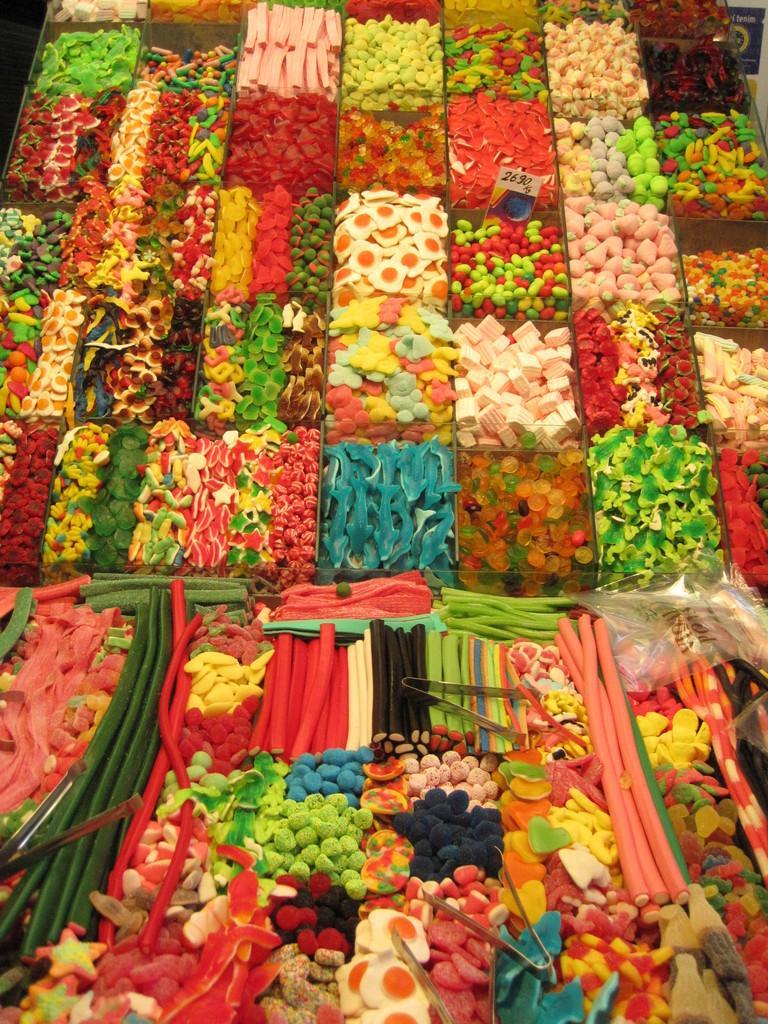Could you give a brief overview of what you see in this image? In this picture we can see different types of food items, tongs, price tag and some objects. 